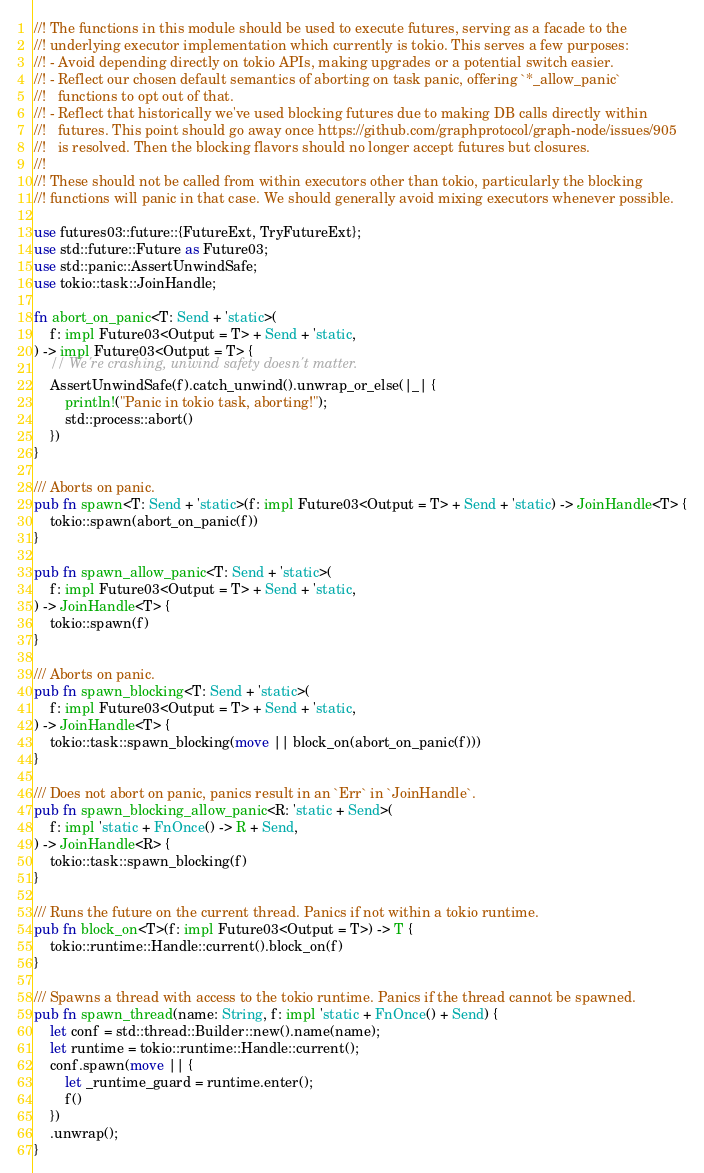Convert code to text. <code><loc_0><loc_0><loc_500><loc_500><_Rust_>//! The functions in this module should be used to execute futures, serving as a facade to the
//! underlying executor implementation which currently is tokio. This serves a few purposes:
//! - Avoid depending directly on tokio APIs, making upgrades or a potential switch easier.
//! - Reflect our chosen default semantics of aborting on task panic, offering `*_allow_panic`
//!   functions to opt out of that.
//! - Reflect that historically we've used blocking futures due to making DB calls directly within
//!   futures. This point should go away once https://github.com/graphprotocol/graph-node/issues/905
//!   is resolved. Then the blocking flavors should no longer accept futures but closures.
//!
//! These should not be called from within executors other than tokio, particularly the blocking
//! functions will panic in that case. We should generally avoid mixing executors whenever possible.

use futures03::future::{FutureExt, TryFutureExt};
use std::future::Future as Future03;
use std::panic::AssertUnwindSafe;
use tokio::task::JoinHandle;

fn abort_on_panic<T: Send + 'static>(
    f: impl Future03<Output = T> + Send + 'static,
) -> impl Future03<Output = T> {
    // We're crashing, unwind safety doesn't matter.
    AssertUnwindSafe(f).catch_unwind().unwrap_or_else(|_| {
        println!("Panic in tokio task, aborting!");
        std::process::abort()
    })
}

/// Aborts on panic.
pub fn spawn<T: Send + 'static>(f: impl Future03<Output = T> + Send + 'static) -> JoinHandle<T> {
    tokio::spawn(abort_on_panic(f))
}

pub fn spawn_allow_panic<T: Send + 'static>(
    f: impl Future03<Output = T> + Send + 'static,
) -> JoinHandle<T> {
    tokio::spawn(f)
}

/// Aborts on panic.
pub fn spawn_blocking<T: Send + 'static>(
    f: impl Future03<Output = T> + Send + 'static,
) -> JoinHandle<T> {
    tokio::task::spawn_blocking(move || block_on(abort_on_panic(f)))
}

/// Does not abort on panic, panics result in an `Err` in `JoinHandle`.
pub fn spawn_blocking_allow_panic<R: 'static + Send>(
    f: impl 'static + FnOnce() -> R + Send,
) -> JoinHandle<R> {
    tokio::task::spawn_blocking(f)
}

/// Runs the future on the current thread. Panics if not within a tokio runtime.
pub fn block_on<T>(f: impl Future03<Output = T>) -> T {
    tokio::runtime::Handle::current().block_on(f)
}

/// Spawns a thread with access to the tokio runtime. Panics if the thread cannot be spawned.
pub fn spawn_thread(name: String, f: impl 'static + FnOnce() + Send) {
    let conf = std::thread::Builder::new().name(name);
    let runtime = tokio::runtime::Handle::current();
    conf.spawn(move || {
        let _runtime_guard = runtime.enter();
        f()
    })
    .unwrap();
}
</code> 